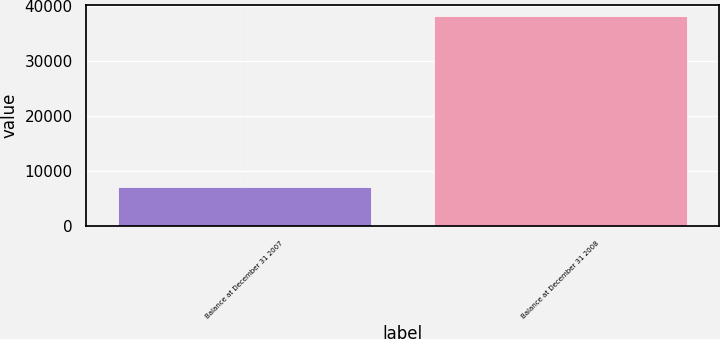<chart> <loc_0><loc_0><loc_500><loc_500><bar_chart><fcel>Balance at December 31 2007<fcel>Balance at December 31 2008<nl><fcel>7165<fcel>38251<nl></chart> 